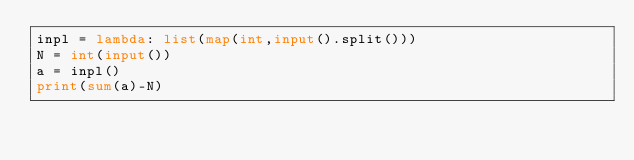<code> <loc_0><loc_0><loc_500><loc_500><_Python_>inpl = lambda: list(map(int,input().split()))
N = int(input())
a = inpl()
print(sum(a)-N)</code> 